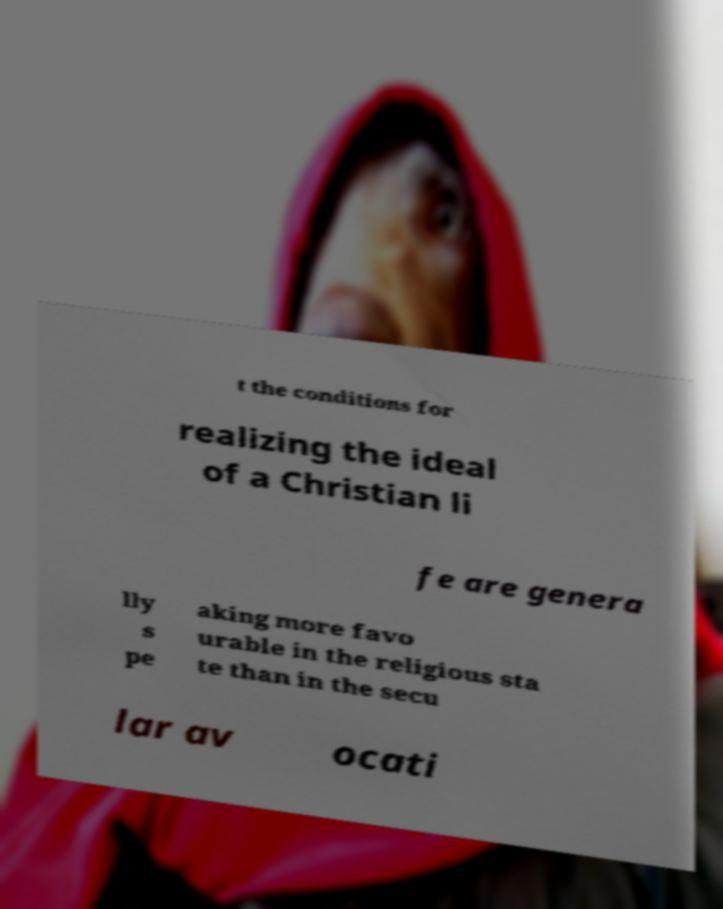For documentation purposes, I need the text within this image transcribed. Could you provide that? t the conditions for realizing the ideal of a Christian li fe are genera lly s pe aking more favo urable in the religious sta te than in the secu lar av ocati 